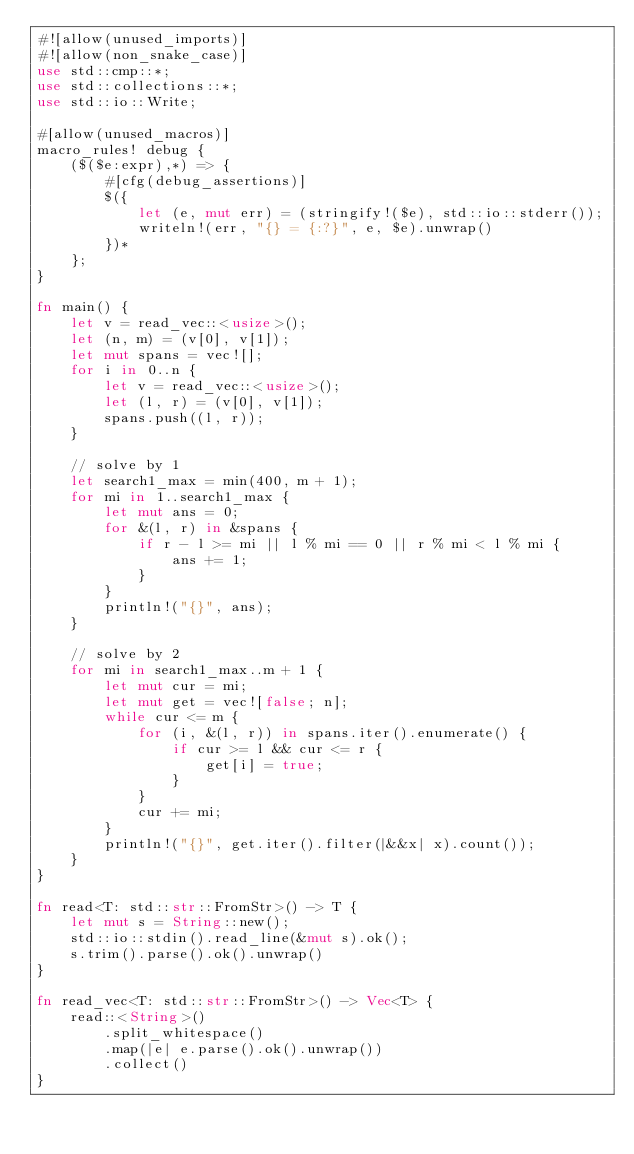Convert code to text. <code><loc_0><loc_0><loc_500><loc_500><_Rust_>#![allow(unused_imports)]
#![allow(non_snake_case)]
use std::cmp::*;
use std::collections::*;
use std::io::Write;

#[allow(unused_macros)]
macro_rules! debug {
    ($($e:expr),*) => {
        #[cfg(debug_assertions)]
        $({
            let (e, mut err) = (stringify!($e), std::io::stderr());
            writeln!(err, "{} = {:?}", e, $e).unwrap()
        })*
    };
}

fn main() {
    let v = read_vec::<usize>();
    let (n, m) = (v[0], v[1]);
    let mut spans = vec![];
    for i in 0..n {
        let v = read_vec::<usize>();
        let (l, r) = (v[0], v[1]);
        spans.push((l, r));
    }

    // solve by 1
    let search1_max = min(400, m + 1);
    for mi in 1..search1_max {
        let mut ans = 0;
        for &(l, r) in &spans {
            if r - l >= mi || l % mi == 0 || r % mi < l % mi {
                ans += 1;
            }
        }
        println!("{}", ans);
    }

    // solve by 2
    for mi in search1_max..m + 1 {
        let mut cur = mi;
        let mut get = vec![false; n];
        while cur <= m {
            for (i, &(l, r)) in spans.iter().enumerate() {
                if cur >= l && cur <= r {
                    get[i] = true;
                }
            }
            cur += mi;
        }
        println!("{}", get.iter().filter(|&&x| x).count());
    }
}

fn read<T: std::str::FromStr>() -> T {
    let mut s = String::new();
    std::io::stdin().read_line(&mut s).ok();
    s.trim().parse().ok().unwrap()
}

fn read_vec<T: std::str::FromStr>() -> Vec<T> {
    read::<String>()
        .split_whitespace()
        .map(|e| e.parse().ok().unwrap())
        .collect()
}
</code> 